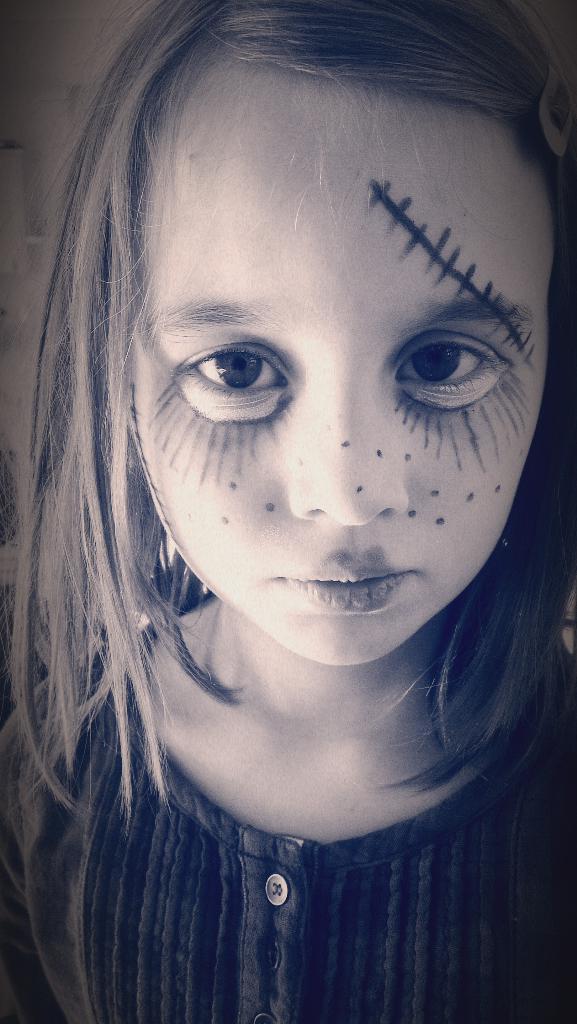How would you summarize this image in a sentence or two? In this picture there is a girl in the center of the image with a painted face. 